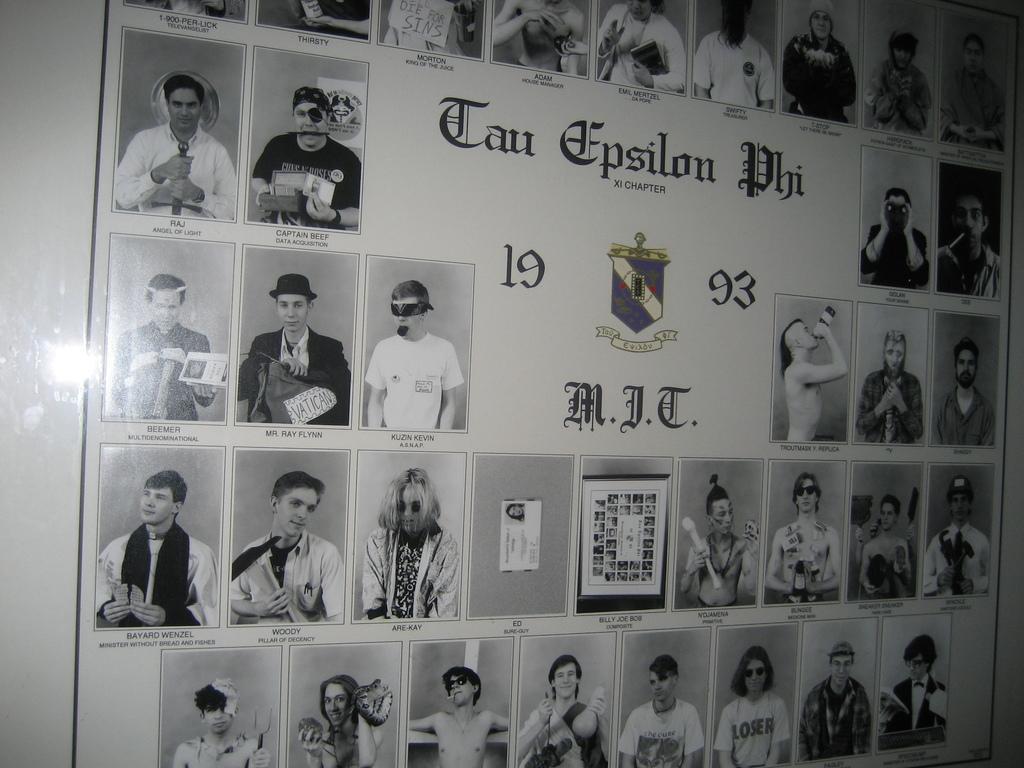In one or two sentences, can you explain what this image depicts? In this picture we can see banner on the wall, on this banner we can see people and some information. 